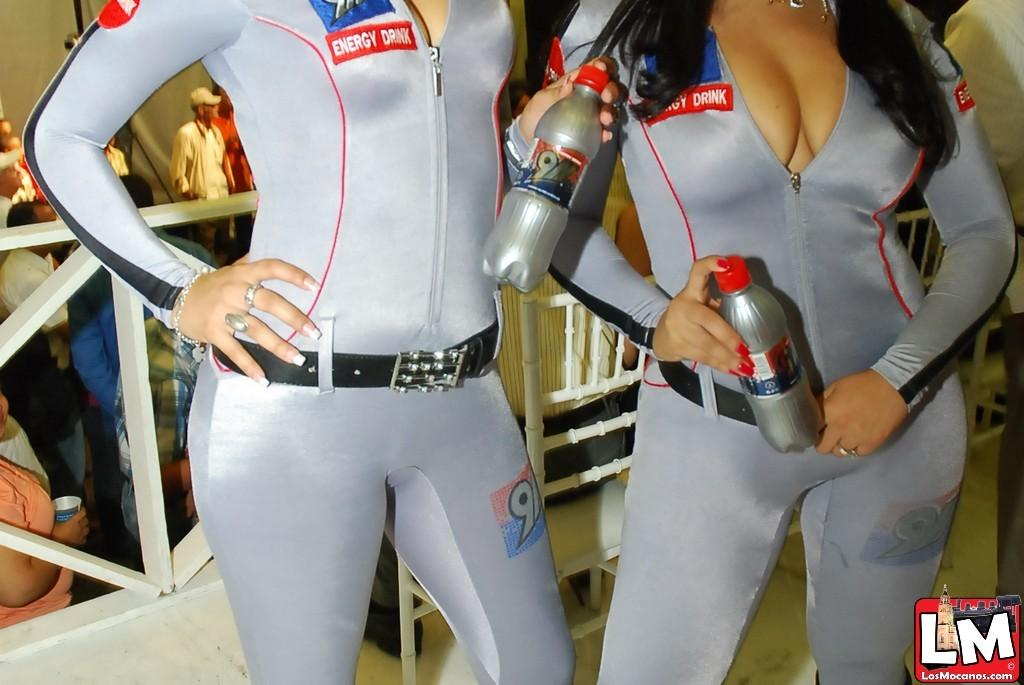<image>
Render a clear and concise summary of the photo. Two women in tight grey clothes with Energy Drink written on them 